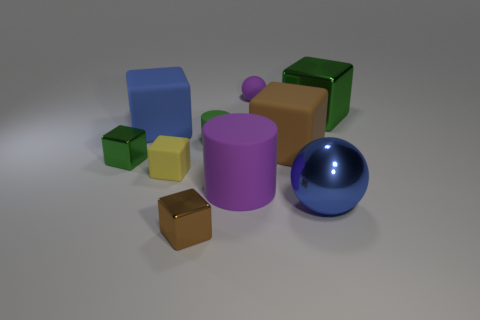The large sphere has what color?
Your response must be concise. Blue. How many objects are either small cylinders or gray spheres?
Give a very brief answer. 1. Is there a large thing that has the same shape as the small green matte thing?
Offer a terse response. Yes. Is the color of the matte cylinder left of the big purple thing the same as the big metallic block?
Ensure brevity in your answer.  Yes. What shape is the green thing that is on the left side of the brown block that is on the left side of the small purple object?
Offer a very short reply. Cube. Are there any yellow matte blocks that have the same size as the matte sphere?
Provide a succinct answer. Yes. Are there fewer large brown things than matte cylinders?
Provide a short and direct response. Yes. What is the shape of the large blue object that is in front of the tiny green object that is behind the small metallic cube that is on the left side of the big blue cube?
Provide a succinct answer. Sphere. What number of things are tiny things that are in front of the small purple object or big cubes on the left side of the green rubber cylinder?
Offer a terse response. 5. There is a large purple cylinder; are there any purple objects right of it?
Provide a succinct answer. Yes. 